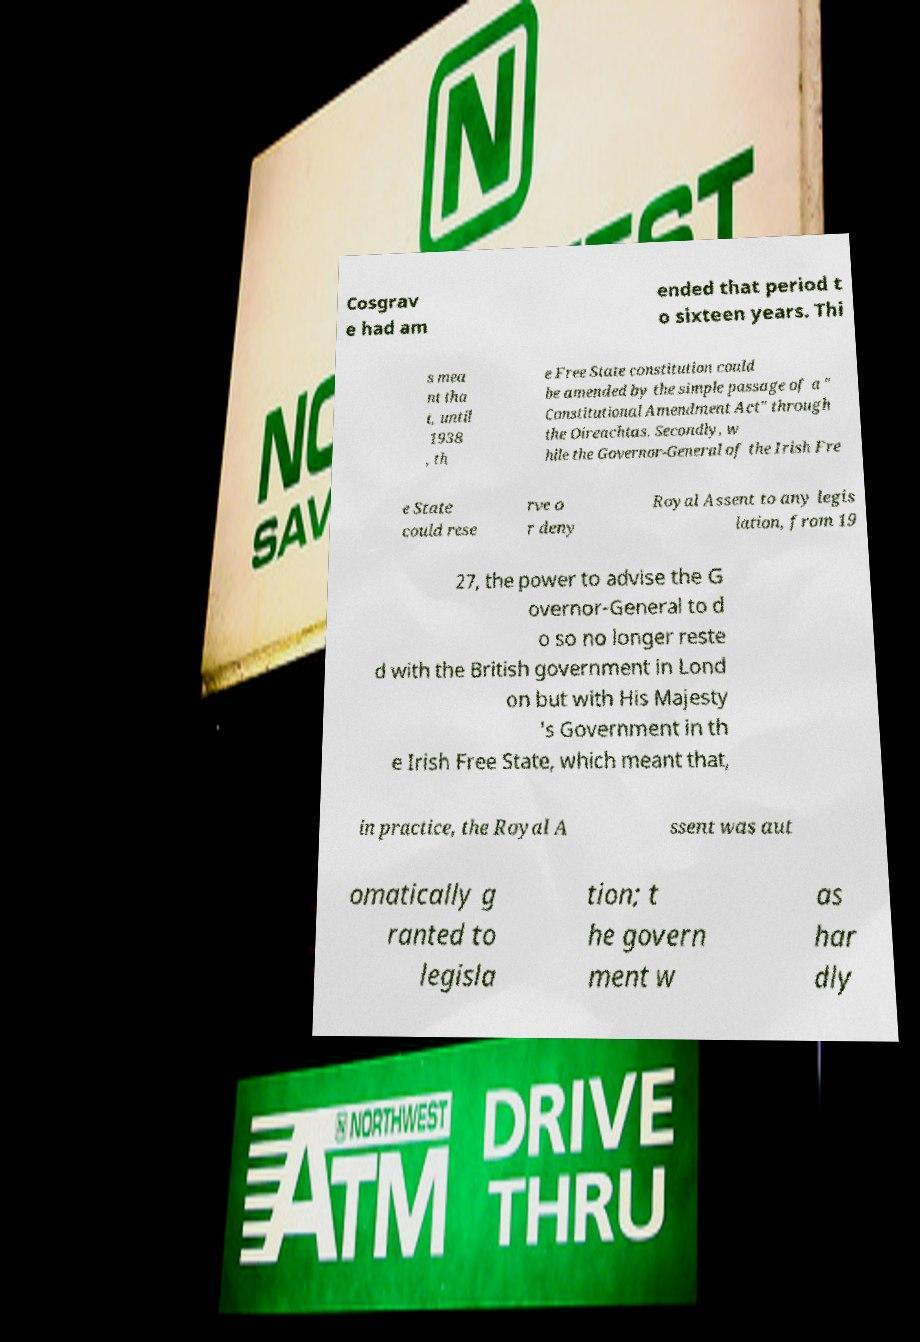There's text embedded in this image that I need extracted. Can you transcribe it verbatim? Cosgrav e had am ended that period t o sixteen years. Thi s mea nt tha t, until 1938 , th e Free State constitution could be amended by the simple passage of a " Constitutional Amendment Act" through the Oireachtas. Secondly, w hile the Governor-General of the Irish Fre e State could rese rve o r deny Royal Assent to any legis lation, from 19 27, the power to advise the G overnor-General to d o so no longer reste d with the British government in Lond on but with His Majesty 's Government in th e Irish Free State, which meant that, in practice, the Royal A ssent was aut omatically g ranted to legisla tion; t he govern ment w as har dly 